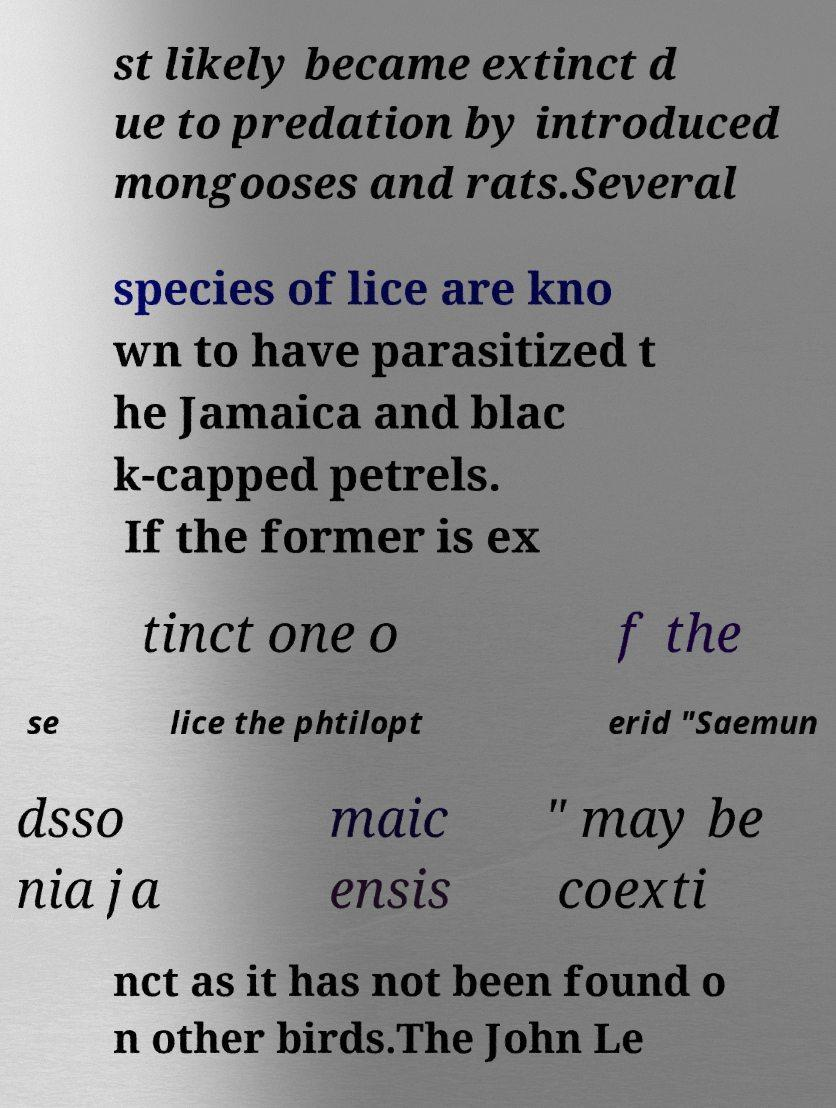What messages or text are displayed in this image? I need them in a readable, typed format. st likely became extinct d ue to predation by introduced mongooses and rats.Several species of lice are kno wn to have parasitized t he Jamaica and blac k-capped petrels. If the former is ex tinct one o f the se lice the phtilopt erid "Saemun dsso nia ja maic ensis " may be coexti nct as it has not been found o n other birds.The John Le 